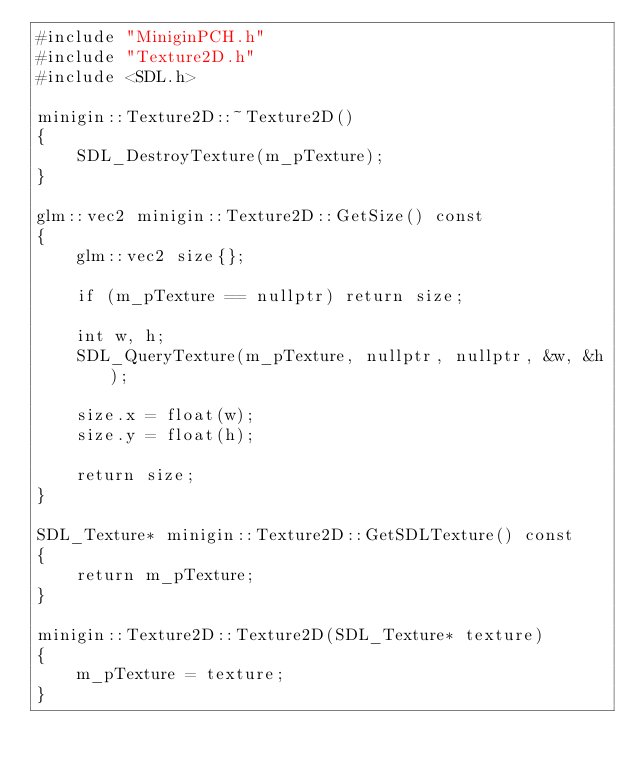<code> <loc_0><loc_0><loc_500><loc_500><_C++_>#include "MiniginPCH.h"
#include "Texture2D.h"
#include <SDL.h>

minigin::Texture2D::~Texture2D()
{
	SDL_DestroyTexture(m_pTexture);
}

glm::vec2 minigin::Texture2D::GetSize() const
{
	glm::vec2 size{};

	if (m_pTexture == nullptr) return size;

	int w, h;
	SDL_QueryTexture(m_pTexture, nullptr, nullptr, &w, &h);

	size.x = float(w);
	size.y = float(h);

	return size;
}

SDL_Texture* minigin::Texture2D::GetSDLTexture() const
{
	return m_pTexture;
}

minigin::Texture2D::Texture2D(SDL_Texture* texture)
{
	m_pTexture = texture;
}
</code> 